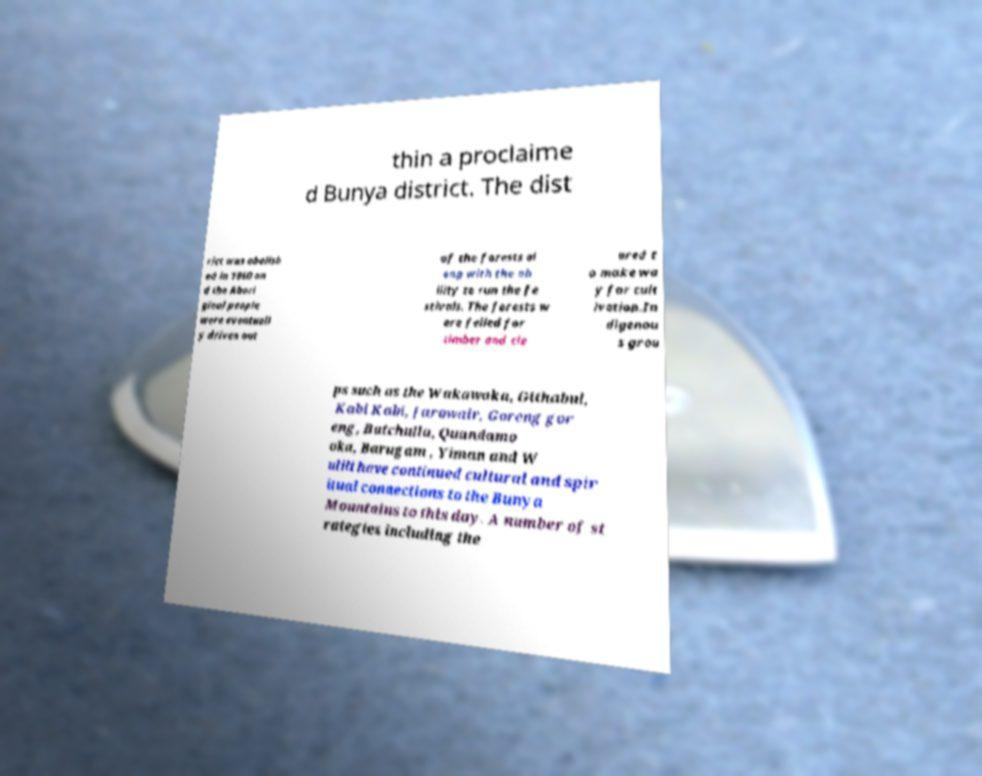Can you read and provide the text displayed in the image?This photo seems to have some interesting text. Can you extract and type it out for me? thin a proclaime d Bunya district. The dist rict was abolish ed in 1860 an d the Abori ginal people were eventuall y driven out of the forests al ong with the ab ility to run the fe stivals. The forests w ere felled for timber and cle ared t o make wa y for cult ivation.In digenou s grou ps such as the Wakawaka, Githabul, Kabi Kabi, Jarowair, Goreng gor eng, Butchulla, Quandamo oka, Barugam , Yiman and W ulili have continued cultural and spir itual connections to the Bunya Mountains to this day. A number of st rategies including the 